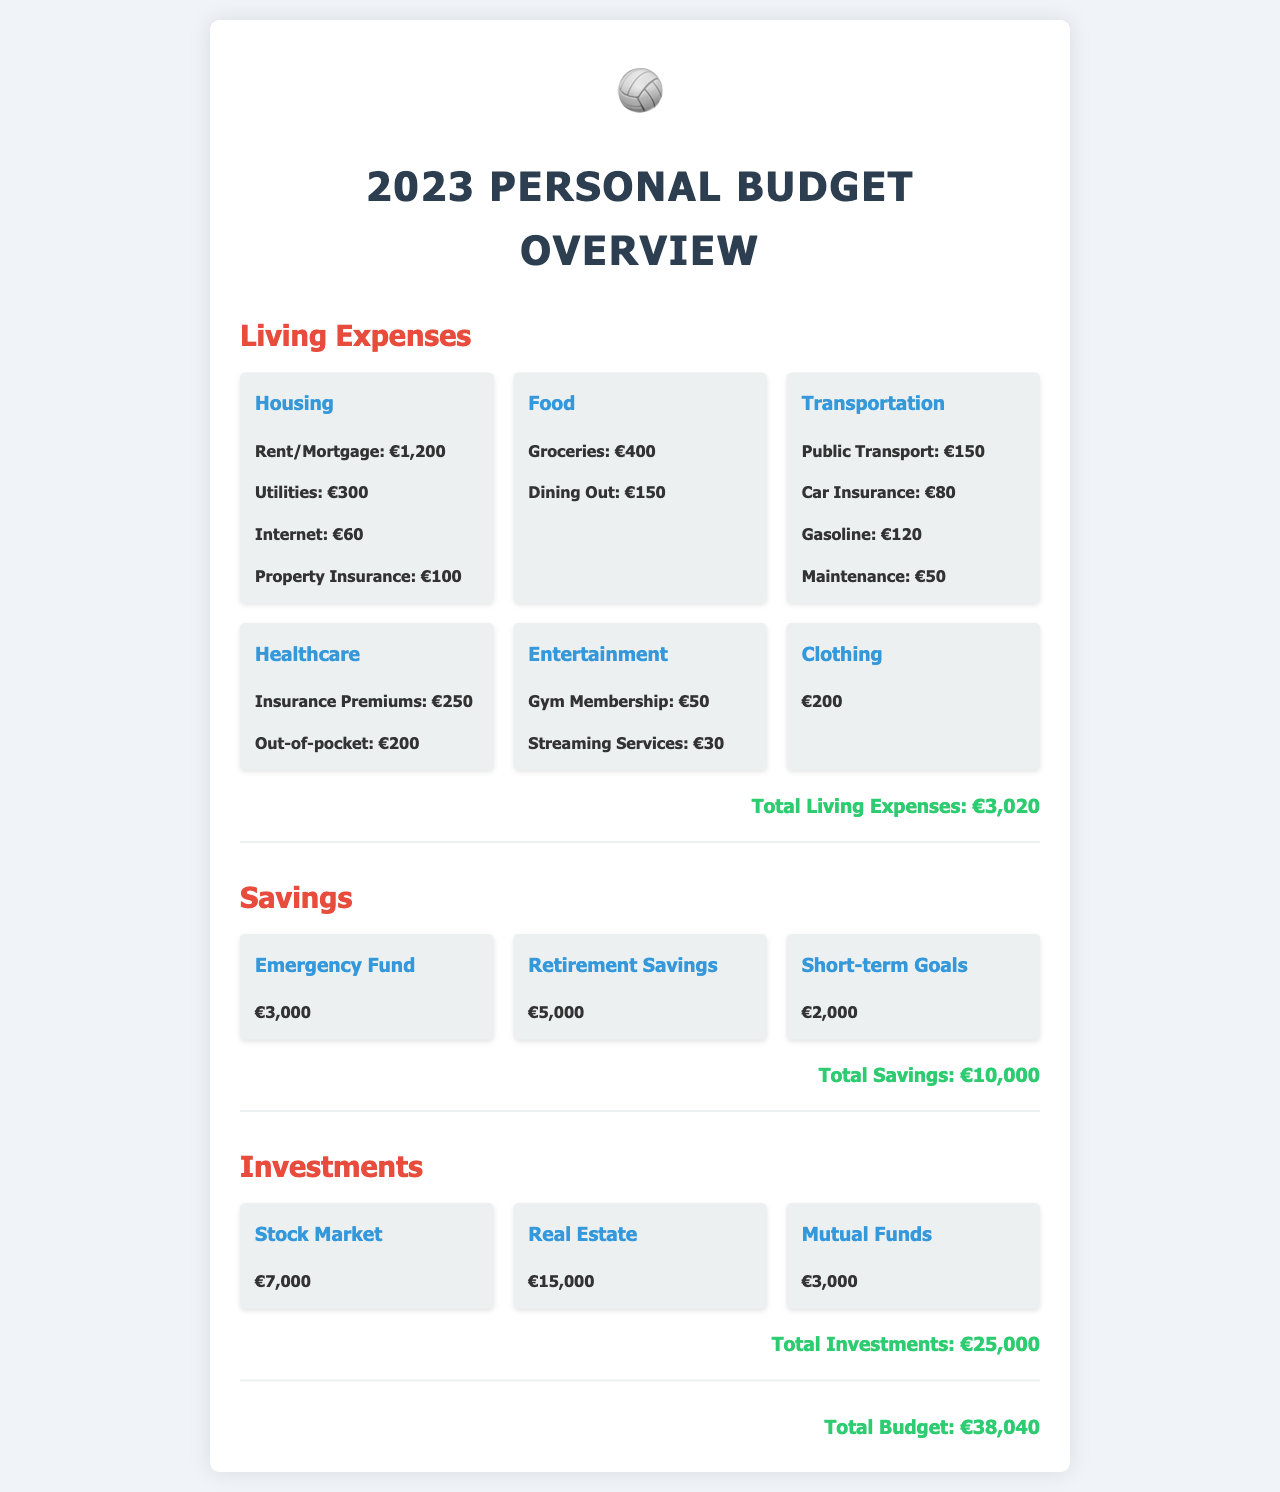What is the total living expenses? The total living expenses is calculated by summing all individual living expense categories, resulting in €3,020.
Answer: €3,020 How much is spent on healthcare? The healthcare expenses include insurance premiums and out-of-pocket costs, totaling €450.
Answer: €450 What is the amount allocated to retirement savings? The document specifies that €5,000 is allocated to retirement savings.
Answer: €5,000 Which category has the highest investment? Real Estate has the highest investment amount listed, which is €15,000.
Answer: Real Estate What is the total budget for the year? The total budget is derived from summing all living expenses, savings, and investments, leading to €38,040.
Answer: €38,040 How much is spent on food? The calculated total for food expenses, including groceries and dining out, is €550.
Answer: €550 What is the amount in the emergency fund? The emergency fund is allocated a total of €3,000 as per the document.
Answer: €3,000 What is the total amount in mutual funds? The document states that investments in mutual funds total €3,000.
Answer: €3,000 Which living expense has the highest individual cost? Housing has the highest individual cost, with rent/mortgage expenses amounting to €1,200.
Answer: Housing 